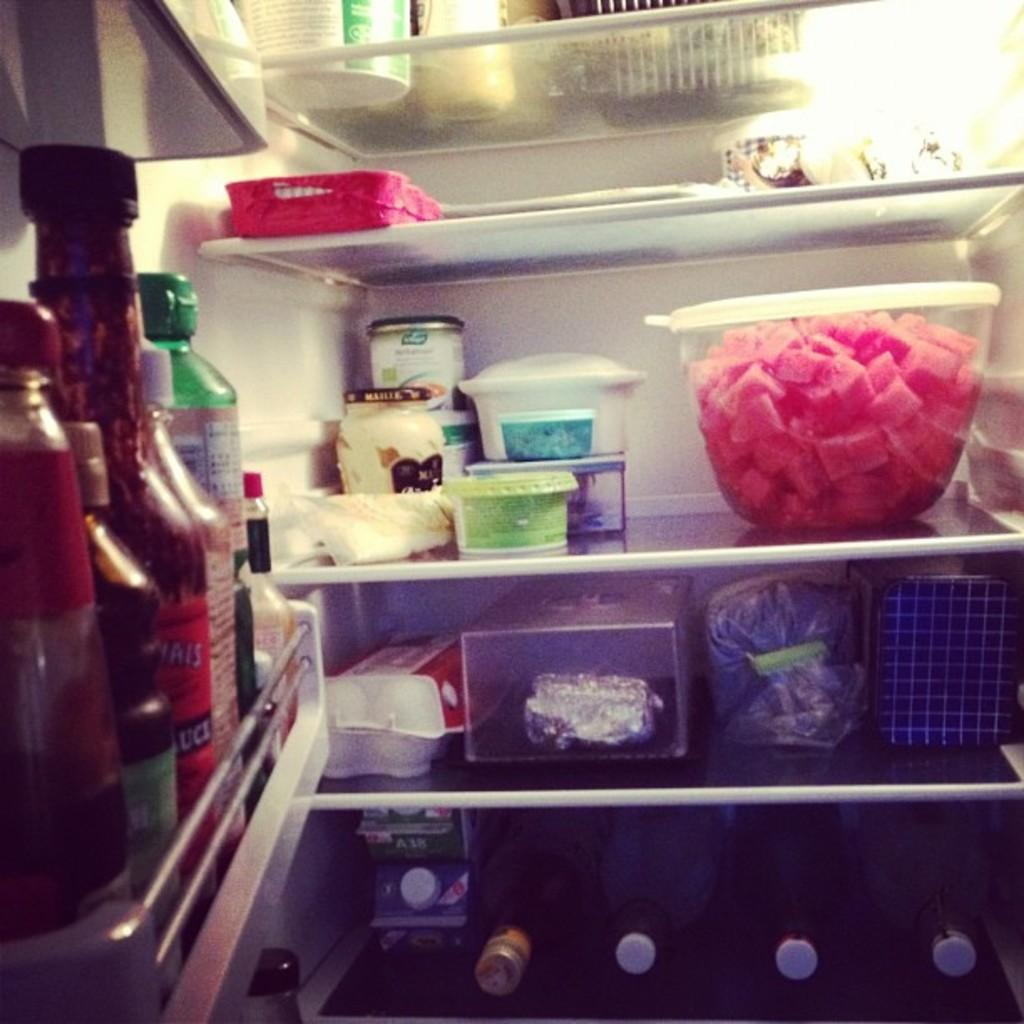What is the setting of the image? The image is of the inside part of a refrigerator. Where are the bottles located in the refrigerator? The bottles are on the left side of the refrigerator. What type of food can be seen in the image? There are food pieces in a container in the refrigerator. What type of jewel is placed on the band in the image? There is no band or jewel present in the image; it is a picture of the inside of a refrigerator. 